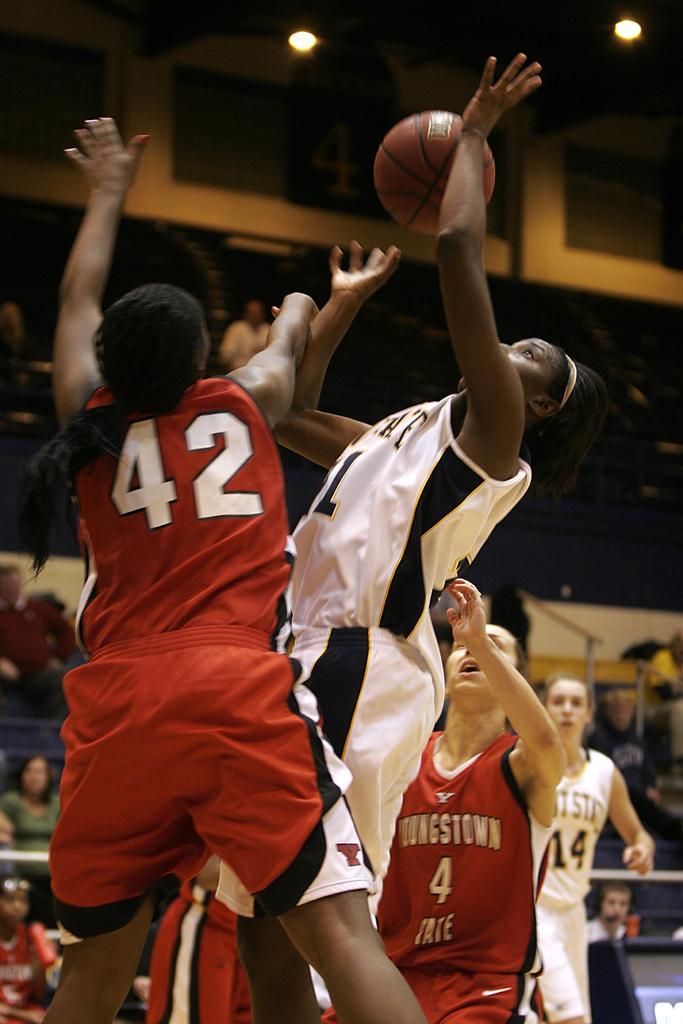Please provide a concise description of this image. In this image we can see a few people are playing basketball. There are few audience are watching the game. 